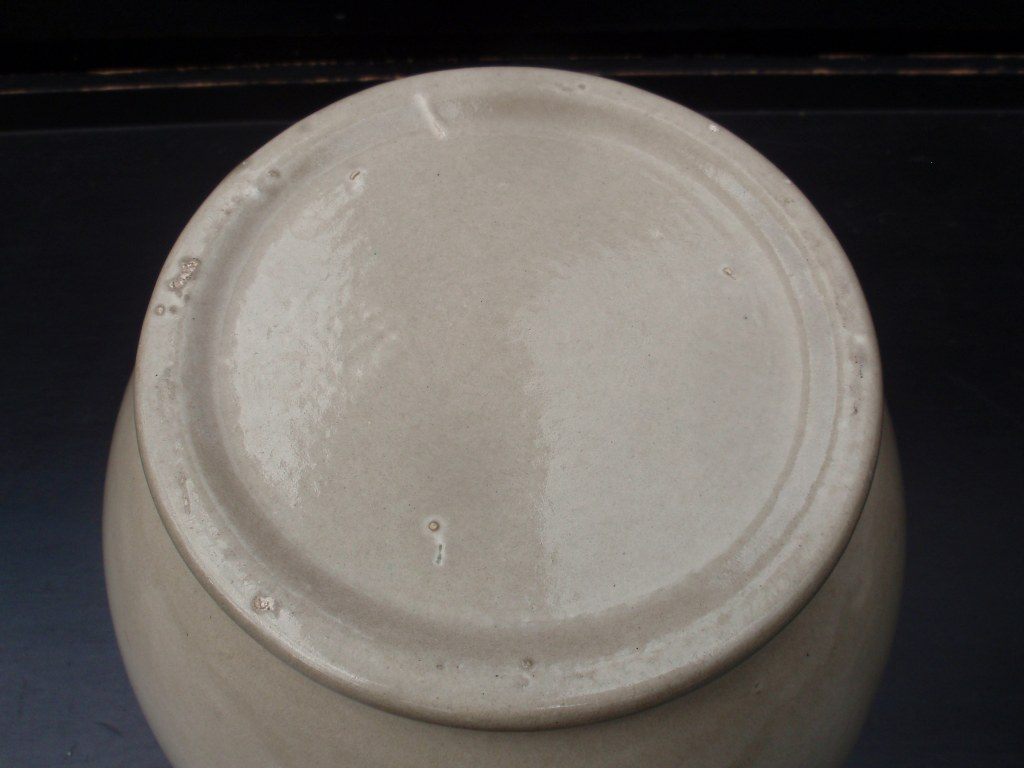Imagine a story involving this object in a magical world. What role does it play? In a magical world, this humble pot is actually a Vessel of Whispers. Crafted by a legendary potter under a rare celestial event, it has the power to transmit messages across vast distances. Only those with pure intentions can hear the whispers emanating from it, guiding them to hidden treasures or forgotten knowledge. Adventurers and scholars seek it out, hoping to uncover its secrets and the mysteries it guards. 